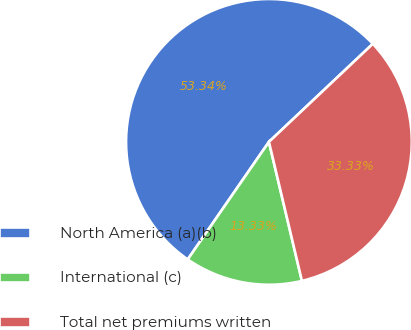<chart> <loc_0><loc_0><loc_500><loc_500><pie_chart><fcel>North America (a)(b)<fcel>International (c)<fcel>Total net premiums written<nl><fcel>53.33%<fcel>13.33%<fcel>33.33%<nl></chart> 